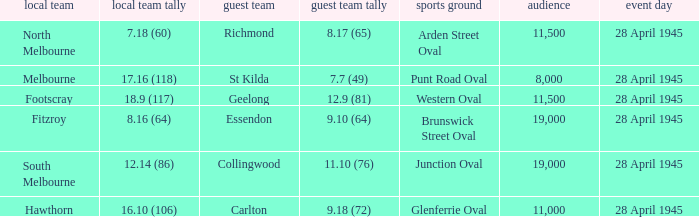Which away team has a Home team score of 12.14 (86)? 11.10 (76). 